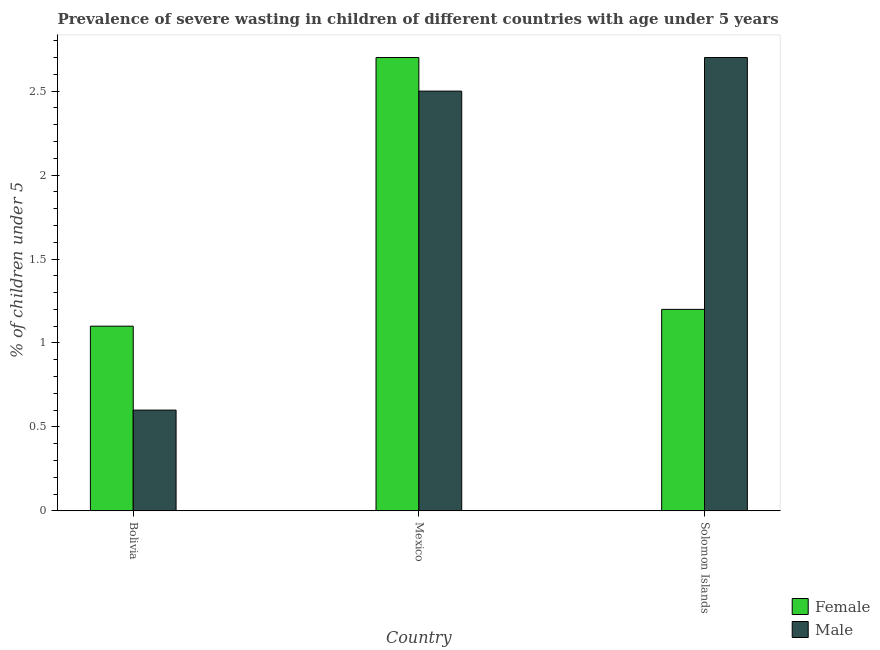Are the number of bars per tick equal to the number of legend labels?
Your answer should be compact. Yes. Are the number of bars on each tick of the X-axis equal?
Make the answer very short. Yes. How many bars are there on the 2nd tick from the left?
Make the answer very short. 2. How many bars are there on the 3rd tick from the right?
Make the answer very short. 2. What is the label of the 3rd group of bars from the left?
Ensure brevity in your answer.  Solomon Islands. What is the percentage of undernourished male children in Solomon Islands?
Provide a short and direct response. 2.7. Across all countries, what is the maximum percentage of undernourished male children?
Ensure brevity in your answer.  2.7. Across all countries, what is the minimum percentage of undernourished female children?
Your answer should be compact. 1.1. In which country was the percentage of undernourished male children maximum?
Your answer should be compact. Solomon Islands. In which country was the percentage of undernourished female children minimum?
Your answer should be compact. Bolivia. What is the total percentage of undernourished male children in the graph?
Your answer should be very brief. 5.8. What is the difference between the percentage of undernourished female children in Mexico and that in Solomon Islands?
Ensure brevity in your answer.  1.5. What is the average percentage of undernourished male children per country?
Offer a very short reply. 1.93. What is the difference between the percentage of undernourished female children and percentage of undernourished male children in Mexico?
Provide a succinct answer. 0.2. In how many countries, is the percentage of undernourished male children greater than 2.6 %?
Provide a short and direct response. 1. What is the ratio of the percentage of undernourished female children in Mexico to that in Solomon Islands?
Give a very brief answer. 2.25. Is the difference between the percentage of undernourished male children in Bolivia and Mexico greater than the difference between the percentage of undernourished female children in Bolivia and Mexico?
Give a very brief answer. No. What is the difference between the highest and the second highest percentage of undernourished female children?
Keep it short and to the point. 1.5. What is the difference between the highest and the lowest percentage of undernourished male children?
Your answer should be compact. 2.1. Is the sum of the percentage of undernourished female children in Mexico and Solomon Islands greater than the maximum percentage of undernourished male children across all countries?
Your answer should be very brief. Yes. How many bars are there?
Offer a terse response. 6. What is the difference between two consecutive major ticks on the Y-axis?
Provide a succinct answer. 0.5. Does the graph contain grids?
Give a very brief answer. No. Where does the legend appear in the graph?
Offer a terse response. Bottom right. How many legend labels are there?
Your response must be concise. 2. How are the legend labels stacked?
Provide a short and direct response. Vertical. What is the title of the graph?
Ensure brevity in your answer.  Prevalence of severe wasting in children of different countries with age under 5 years. Does "Private consumption" appear as one of the legend labels in the graph?
Your answer should be very brief. No. What is the label or title of the X-axis?
Offer a very short reply. Country. What is the label or title of the Y-axis?
Provide a succinct answer.  % of children under 5. What is the  % of children under 5 of Female in Bolivia?
Give a very brief answer. 1.1. What is the  % of children under 5 in Male in Bolivia?
Provide a short and direct response. 0.6. What is the  % of children under 5 in Female in Mexico?
Your response must be concise. 2.7. What is the  % of children under 5 in Female in Solomon Islands?
Give a very brief answer. 1.2. What is the  % of children under 5 in Male in Solomon Islands?
Offer a terse response. 2.7. Across all countries, what is the maximum  % of children under 5 of Female?
Your answer should be compact. 2.7. Across all countries, what is the maximum  % of children under 5 of Male?
Offer a terse response. 2.7. Across all countries, what is the minimum  % of children under 5 in Female?
Make the answer very short. 1.1. Across all countries, what is the minimum  % of children under 5 of Male?
Offer a very short reply. 0.6. What is the total  % of children under 5 in Female in the graph?
Keep it short and to the point. 5. What is the difference between the  % of children under 5 of Female in Bolivia and that in Mexico?
Your response must be concise. -1.6. What is the difference between the  % of children under 5 in Male in Bolivia and that in Mexico?
Make the answer very short. -1.9. What is the difference between the  % of children under 5 in Female in Bolivia and the  % of children under 5 in Male in Mexico?
Your answer should be very brief. -1.4. What is the difference between the  % of children under 5 of Female in Mexico and the  % of children under 5 of Male in Solomon Islands?
Offer a terse response. 0. What is the average  % of children under 5 of Male per country?
Your response must be concise. 1.93. What is the difference between the  % of children under 5 in Female and  % of children under 5 in Male in Bolivia?
Your answer should be very brief. 0.5. What is the difference between the  % of children under 5 of Female and  % of children under 5 of Male in Solomon Islands?
Offer a terse response. -1.5. What is the ratio of the  % of children under 5 in Female in Bolivia to that in Mexico?
Make the answer very short. 0.41. What is the ratio of the  % of children under 5 of Male in Bolivia to that in Mexico?
Your answer should be compact. 0.24. What is the ratio of the  % of children under 5 of Male in Bolivia to that in Solomon Islands?
Provide a succinct answer. 0.22. What is the ratio of the  % of children under 5 of Female in Mexico to that in Solomon Islands?
Your response must be concise. 2.25. What is the ratio of the  % of children under 5 in Male in Mexico to that in Solomon Islands?
Your response must be concise. 0.93. What is the difference between the highest and the lowest  % of children under 5 in Female?
Your answer should be compact. 1.6. 